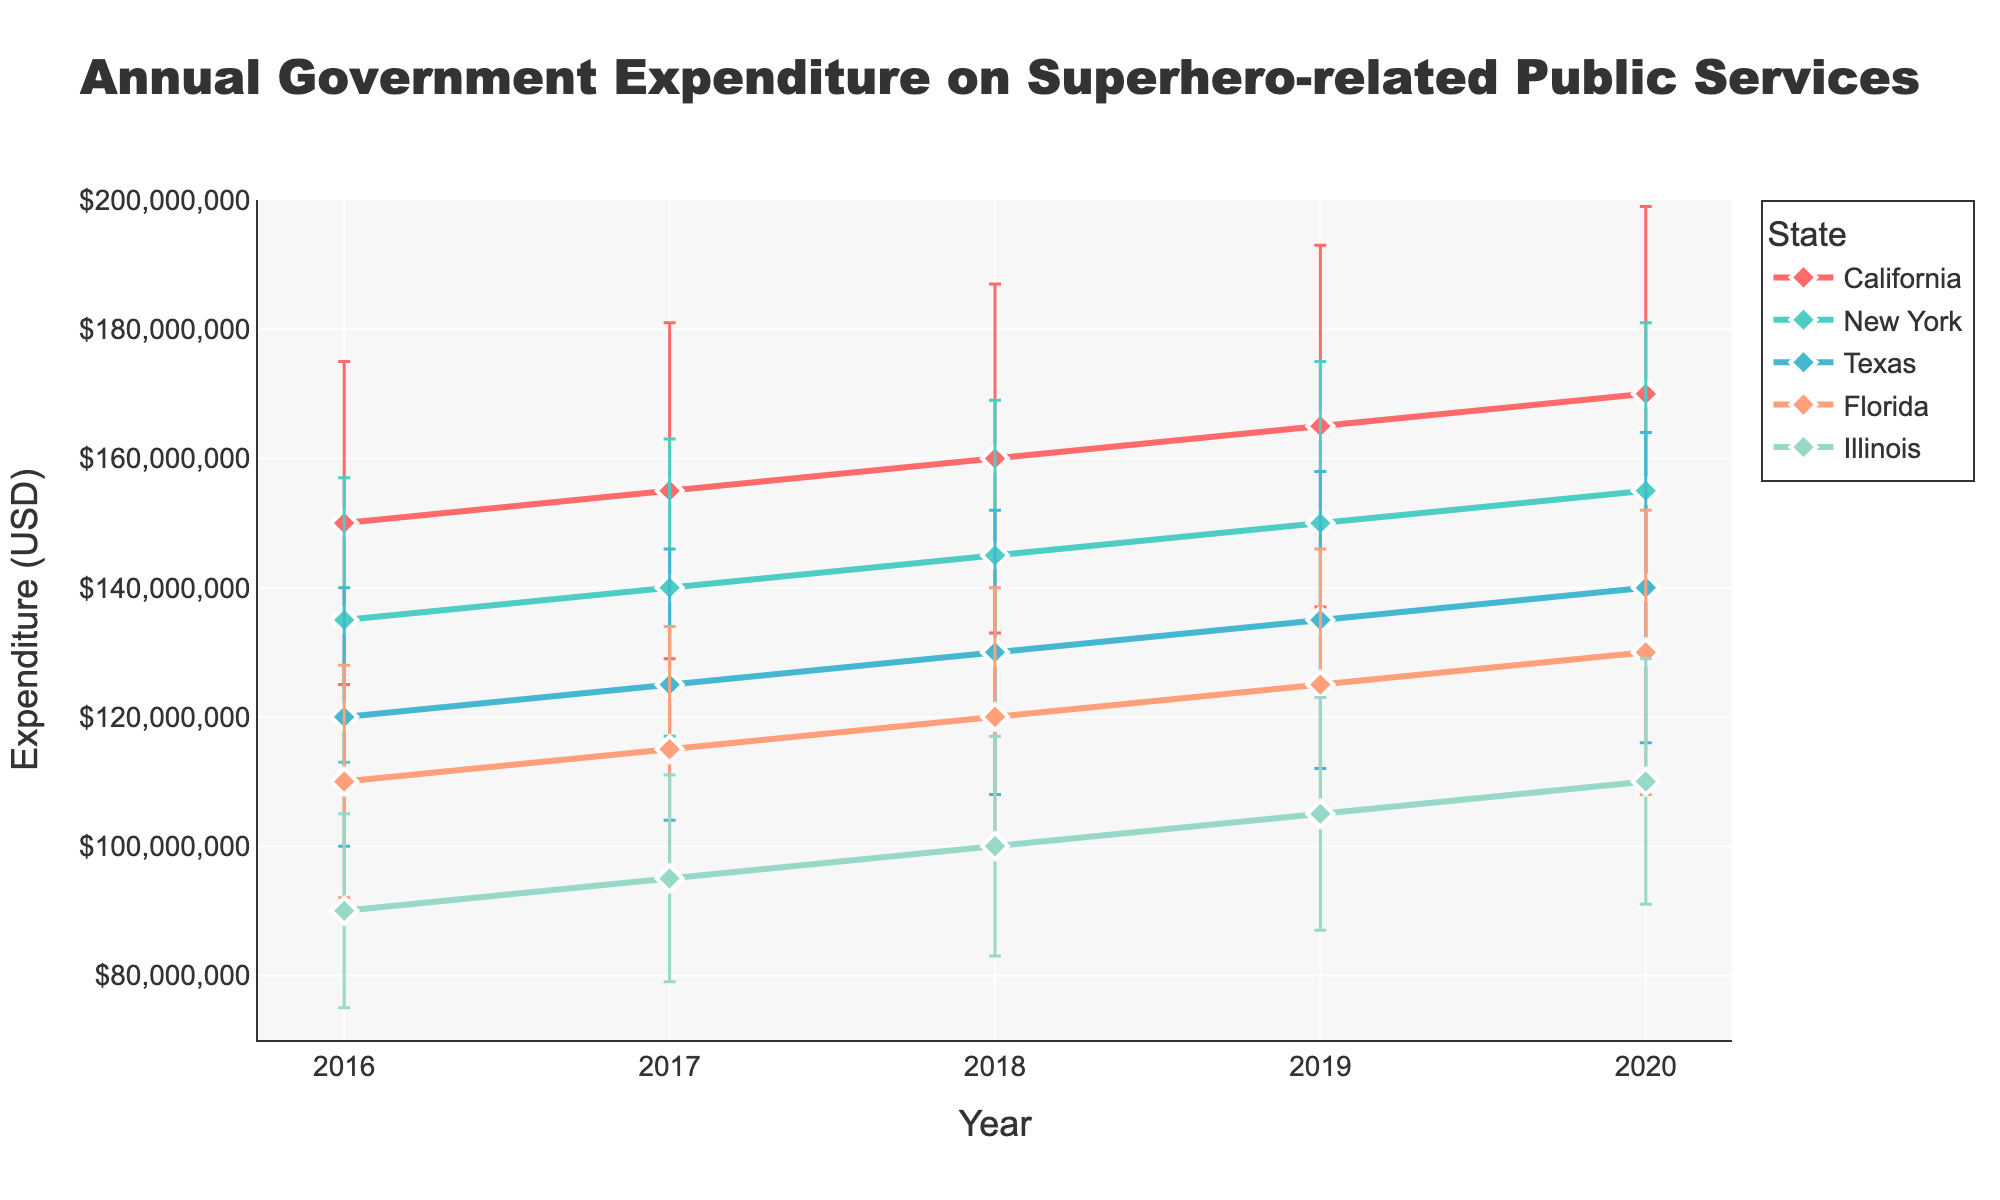What is the title of the figure? The title of the figure is displayed at the top of the plot. It reads "Annual Government Expenditure on Superhero-related Public Services".
Answer: Annual Government Expenditure on Superhero-related Public Services Which state had the highest mean expenditure in 2020? Looking at the data points for the year 2020, the state with the highest mean expenditure is represented by the highest point among the states. California has the highest mean expenditure in 2020.
Answer: California What was the mean expenditure for Texas in 2016? The mean expenditure for Texas in 2016 can be found by locating the point on the line for Texas corresponding to the year 2016. The mean expenditure for Texas in 2016 is 120,000,000 USD.
Answer: 120,000,000 USD How does the mean expenditure in Florida change from 2018 to 2019? By comparing the data points for Florida from 2018 to 2019, you can see how the value changes. In 2018, it was 120,000,000 USD, and in 2019, it increased to 125,000,000 USD, so the change is an increase of 5,000,000 USD.
Answer: Increased by 5,000,000 USD Which state shows the largest increase in mean expenditure from 2016 to 2020? To determine the state with the largest increase, calculate the difference in mean expenditure from 2016 to 2020 for each state and compare. California increases from 150,000,000 USD in 2016 to 170,000,000 USD in 2020, which is the largest increase of 20,000,000 USD.
Answer: California What is the mean expenditure of Illinois in 2017 and 2018, and how do they compare? Look at the mean expenditure points for Illinois for the years 2017 and 2018. In 2017, it is 95,000,000 USD; in 2018, it is 100,000,000 USD. Comparing them shows an increase of 5,000,000 USD from 2017 to 2018.
Answer: 95,000,000 USD in 2017, 100,000,000 USD in 2018, increased by 5,000,000 USD Which state maintained a steady increase in mean expenditure every year from 2016 to 2020? A steady increase means the expenditure increases every consecutive year without any drops. Reviewing the trends, California shows a consistent increase each year from 150,000,000 USD in 2016 to 170,000,000 USD in 2020.
Answer: California What was the average mean expenditure across all states in 2019? To find the average mean expenditure for 2019, sum the mean expenditures for all states (165,000,000 + 150,000,000 + 135,000,000 + 125,000,000 + 105,000,000 = 680,000,000 USD) and divide by the number of states (5). The average is 680,000,000 USD / 5 = 136,000,000 USD.
Answer: 136,000,000 USD How large is the error bar for New York's expenditure in 2020 compared to 2018? The error bar represents the standard deviation. In 2020, it is 26,000,000 USD, and in 2018, it is 24,000,000 USD. The difference is 26,000,000 - 24,000,000 = 2,000,000 USD, so the error bar increased by 2,000,000 USD from 2018 to 2020.
Answer: Increased by 2,000,000 USD 